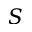<formula> <loc_0><loc_0><loc_500><loc_500>S</formula> 